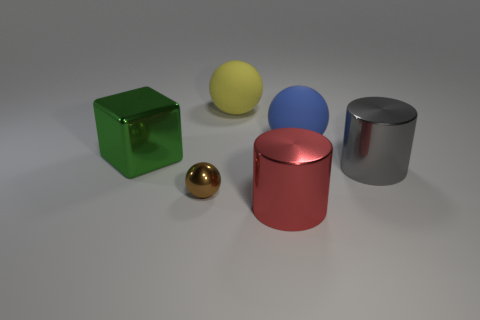Add 3 big green blocks. How many objects exist? 9 Add 5 small shiny spheres. How many small shiny spheres exist? 6 Subtract all yellow balls. How many balls are left? 2 Subtract all brown spheres. How many spheres are left? 2 Subtract 0 blue cylinders. How many objects are left? 6 Subtract all cylinders. How many objects are left? 4 Subtract 2 cylinders. How many cylinders are left? 0 Subtract all purple balls. Subtract all blue cylinders. How many balls are left? 3 Subtract all red balls. How many purple cubes are left? 0 Subtract all brown things. Subtract all small yellow shiny cylinders. How many objects are left? 5 